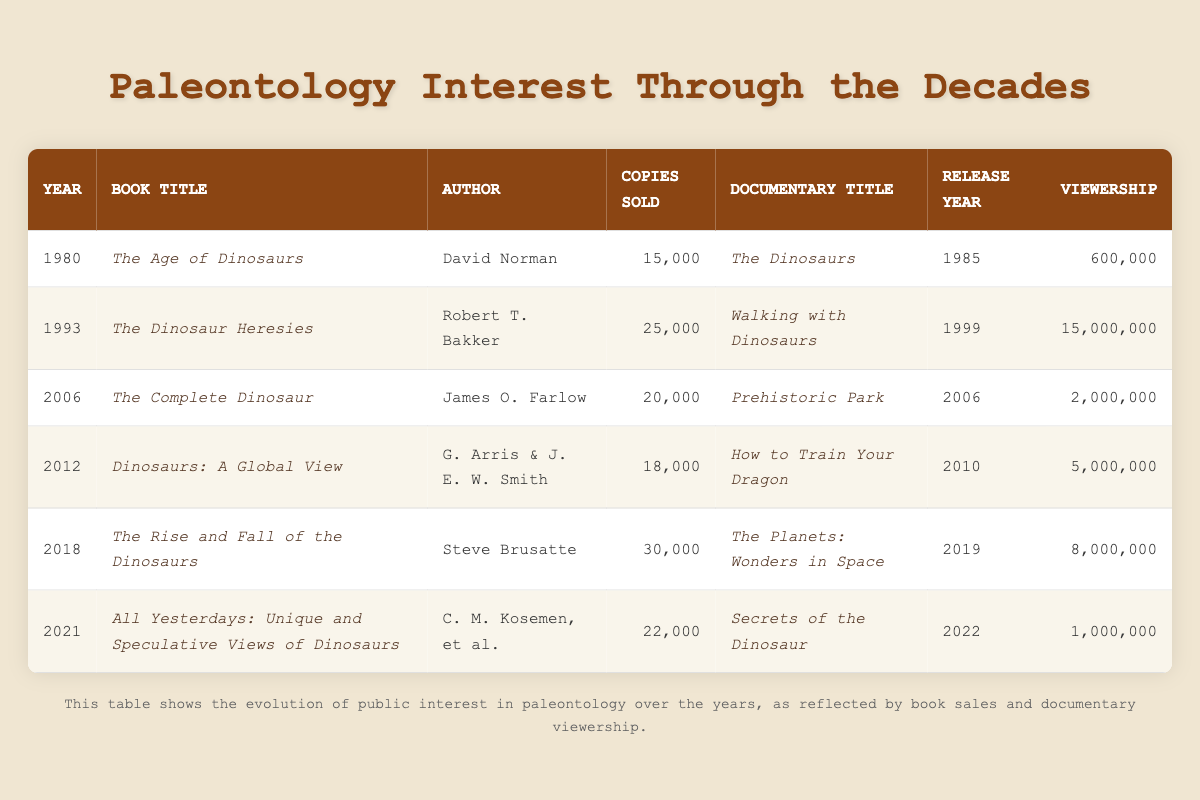What is the title of the book published in 2006? Referring to the table, the row for the year 2006 indicates that the book title is "The Complete Dinosaur."
Answer: The Complete Dinosaur Which author wrote the book "The Rise and Fall of the Dinosaurs"? Looking at the table for the entry with the book title "The Rise and Fall of the Dinosaurs," the corresponding author is Steve Brusatte.
Answer: Steve Brusatte What was the total number of copies sold for books in the years 1980, 1993, and 2006? We need to find the total copies sold for the years 1980 (15,000), 1993 (25,000), and 2006 (20,000). Summing these values gives 15,000 + 25,000 + 20,000 = 60,000.
Answer: 60,000 Did "Walking with Dinosaurs" have a higher viewership than "Secrets of the Dinosaur"? The table shows that "Walking with Dinosaurs" had a viewership of 15,000,000 and "Secrets of the Dinosaur" had a viewership of 1,000,000. Since 15,000,000 is greater than 1,000,000, the statement is true.
Answer: Yes What is the average number of copies sold for all the books listed in the table? To find the average, we first sum the copies sold: 15,000 + 25,000 + 20,000 + 18,000 + 30,000 + 22,000 = 130,000. There are 6 books, so we divide the total by 6: 130,000 / 6 ≈ 21,667.
Answer: Approximately 21,667 Which year saw the highest viewership for a documentary? By examining the viewership figures, 15,000,000 for "Walking with Dinosaurs" in 1999 is the highest compared to other years. Thus, 1999 had the highest viewership for a documentary.
Answer: 1999 How many years apart were the releases of "The Dinosaurs" and "Walking with Dinosaurs"? "The Dinosaurs" was released in 1985 and "Walking with Dinosaurs" was released in 1999. To find the difference: 1999 - 1985 = 14 years.
Answer: 14 years Was there a book and documentary released in the same year in 2006? In 2006, both "The Complete Dinosaur" and "Prehistoric Park" were released. Hence, there was both a book and a documentary released in that year.
Answer: Yes 